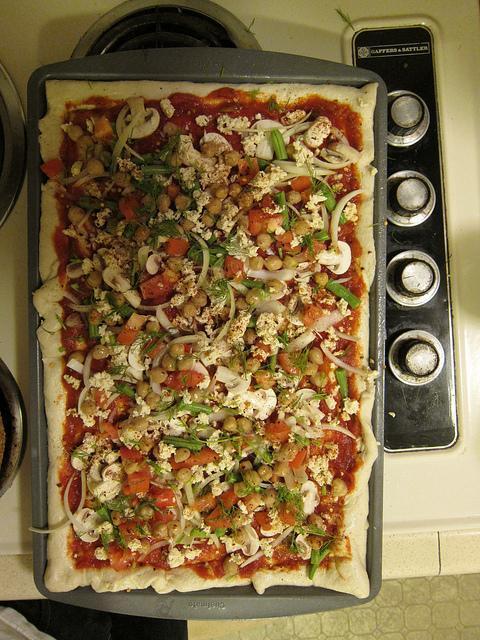Verify the accuracy of this image caption: "The pizza is on the oven.".
Answer yes or no. Yes. 